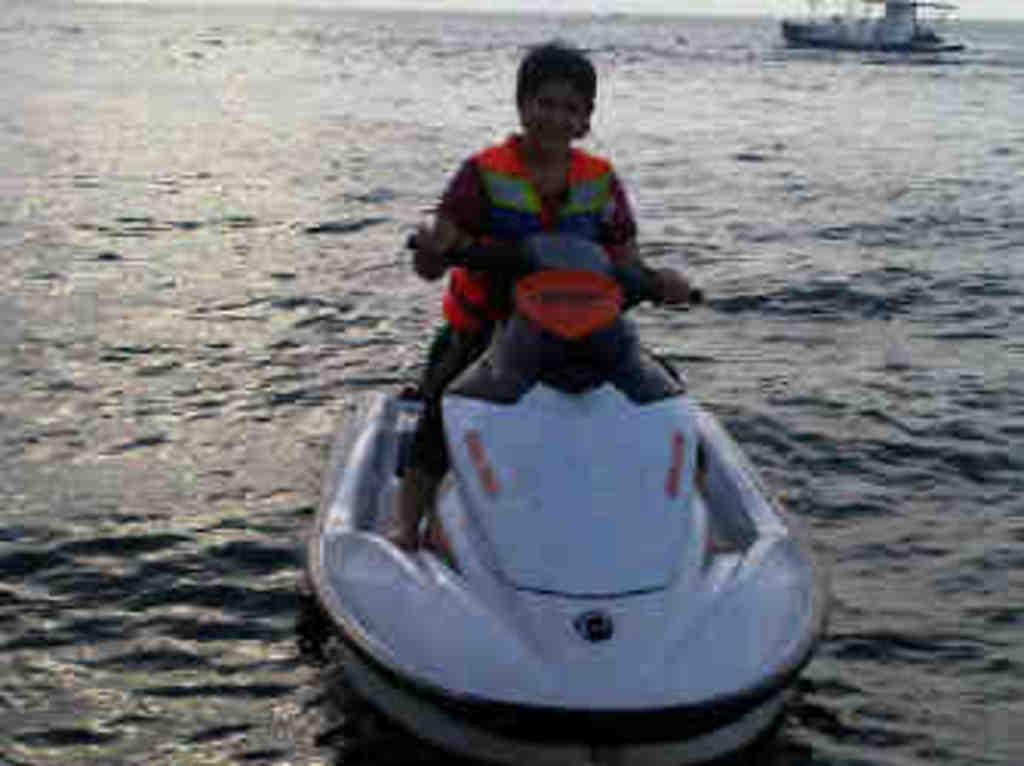Please provide a concise description of this image. In this image there is a person sitting on a boat, which is on the river. In the background there is a ship on the river. 